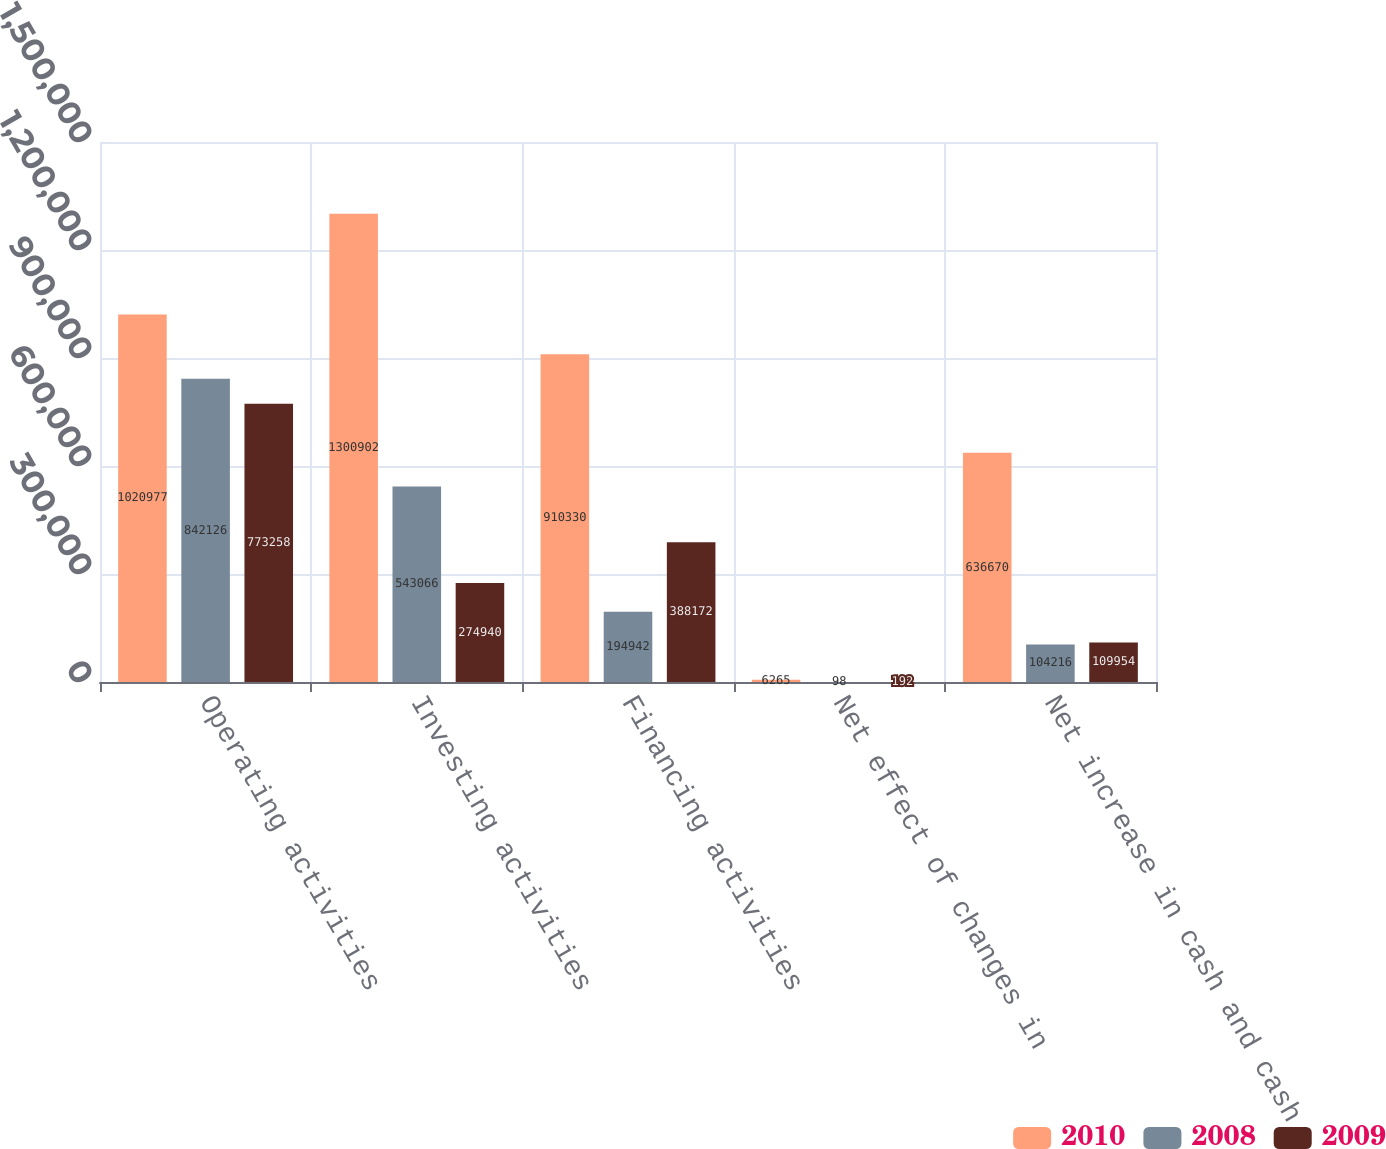Convert chart. <chart><loc_0><loc_0><loc_500><loc_500><stacked_bar_chart><ecel><fcel>Operating activities<fcel>Investing activities<fcel>Financing activities<fcel>Net effect of changes in<fcel>Net increase in cash and cash<nl><fcel>2010<fcel>1.02098e+06<fcel>1.3009e+06<fcel>910330<fcel>6265<fcel>636670<nl><fcel>2008<fcel>842126<fcel>543066<fcel>194942<fcel>98<fcel>104216<nl><fcel>2009<fcel>773258<fcel>274940<fcel>388172<fcel>192<fcel>109954<nl></chart> 